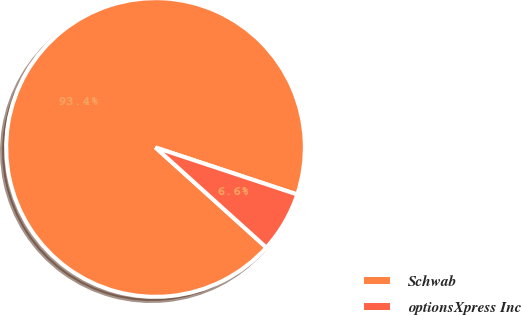<chart> <loc_0><loc_0><loc_500><loc_500><pie_chart><fcel>Schwab<fcel>optionsXpress Inc<nl><fcel>93.41%<fcel>6.59%<nl></chart> 